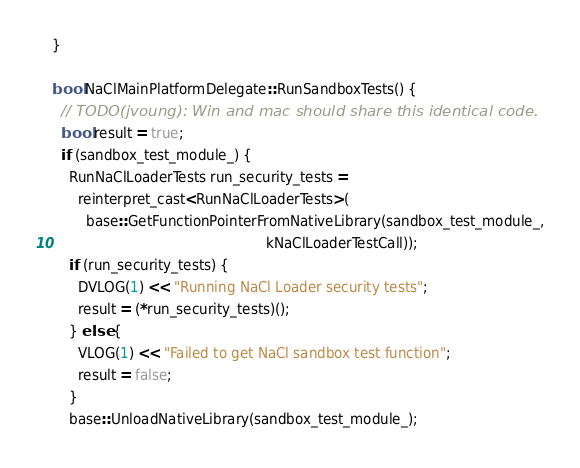Convert code to text. <code><loc_0><loc_0><loc_500><loc_500><_ObjectiveC_>}

bool NaClMainPlatformDelegate::RunSandboxTests() {
  // TODO(jvoung): Win and mac should share this identical code.
  bool result = true;
  if (sandbox_test_module_) {
    RunNaClLoaderTests run_security_tests =
      reinterpret_cast<RunNaClLoaderTests>(
        base::GetFunctionPointerFromNativeLibrary(sandbox_test_module_,
                                                  kNaClLoaderTestCall));
    if (run_security_tests) {
      DVLOG(1) << "Running NaCl Loader security tests";
      result = (*run_security_tests)();
    } else {
      VLOG(1) << "Failed to get NaCl sandbox test function";
      result = false;
    }
    base::UnloadNativeLibrary(sandbox_test_module_);</code> 